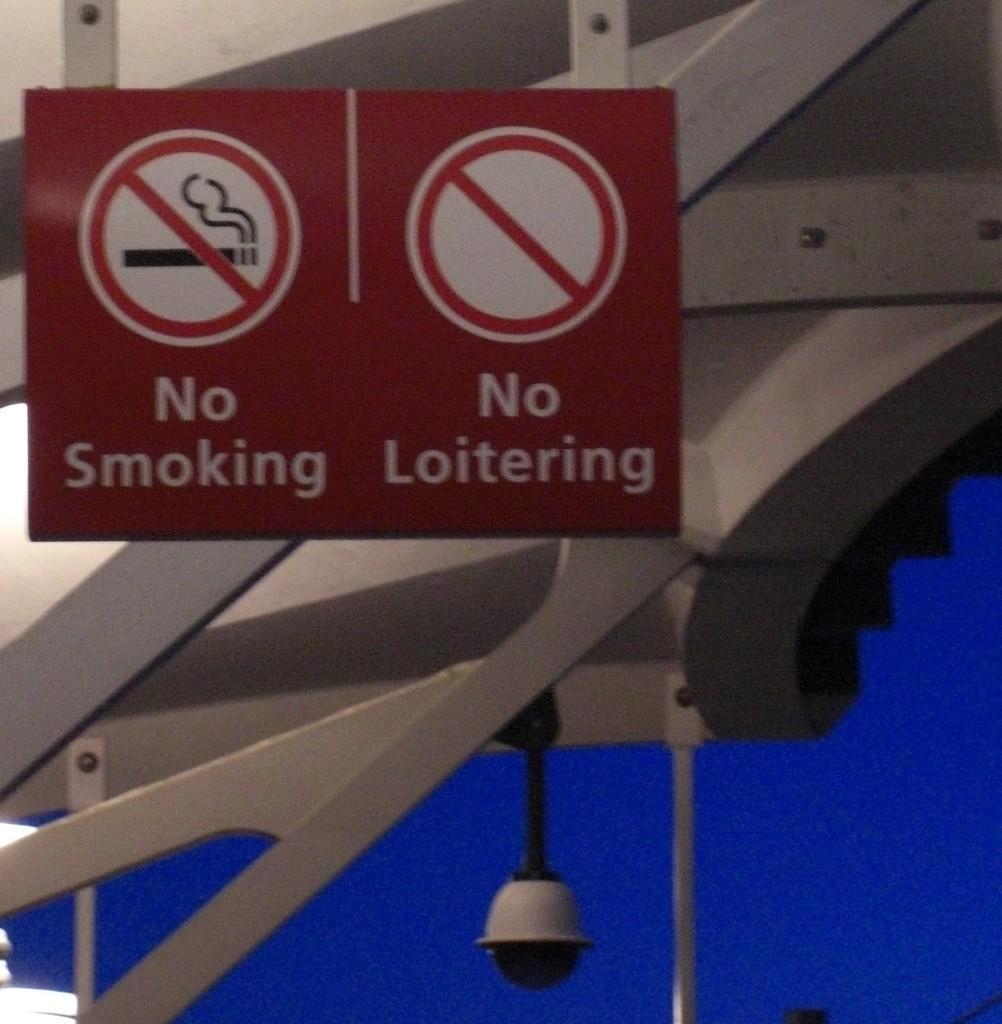Provide a one-sentence caption for the provided image. Twp red signs for no smoking or loitering hanging on the structure. 